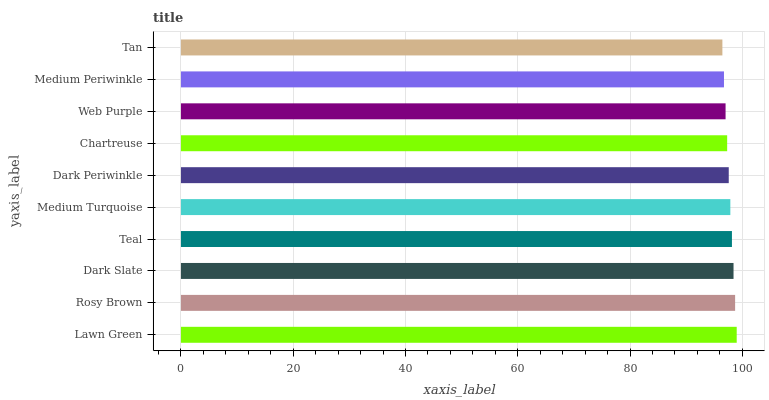Is Tan the minimum?
Answer yes or no. Yes. Is Lawn Green the maximum?
Answer yes or no. Yes. Is Rosy Brown the minimum?
Answer yes or no. No. Is Rosy Brown the maximum?
Answer yes or no. No. Is Lawn Green greater than Rosy Brown?
Answer yes or no. Yes. Is Rosy Brown less than Lawn Green?
Answer yes or no. Yes. Is Rosy Brown greater than Lawn Green?
Answer yes or no. No. Is Lawn Green less than Rosy Brown?
Answer yes or no. No. Is Medium Turquoise the high median?
Answer yes or no. Yes. Is Dark Periwinkle the low median?
Answer yes or no. Yes. Is Lawn Green the high median?
Answer yes or no. No. Is Rosy Brown the low median?
Answer yes or no. No. 